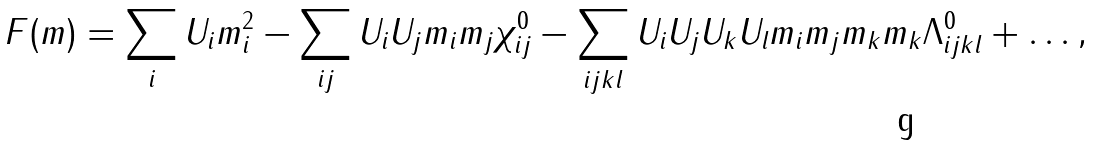Convert formula to latex. <formula><loc_0><loc_0><loc_500><loc_500>F ( { m } ) = \sum _ { i } { U _ { i } m _ { i } ^ { 2 } } - \sum _ { i j } { U _ { i } U _ { j } m _ { i } m _ { j } \chi _ { i j } ^ { 0 } } - \sum _ { i j k l } { U _ { i } U _ { j } U _ { k } U _ { l } m _ { i } m _ { j } m _ { k } m _ { k } \Lambda _ { i j k l } ^ { 0 } } + \dots ,</formula> 